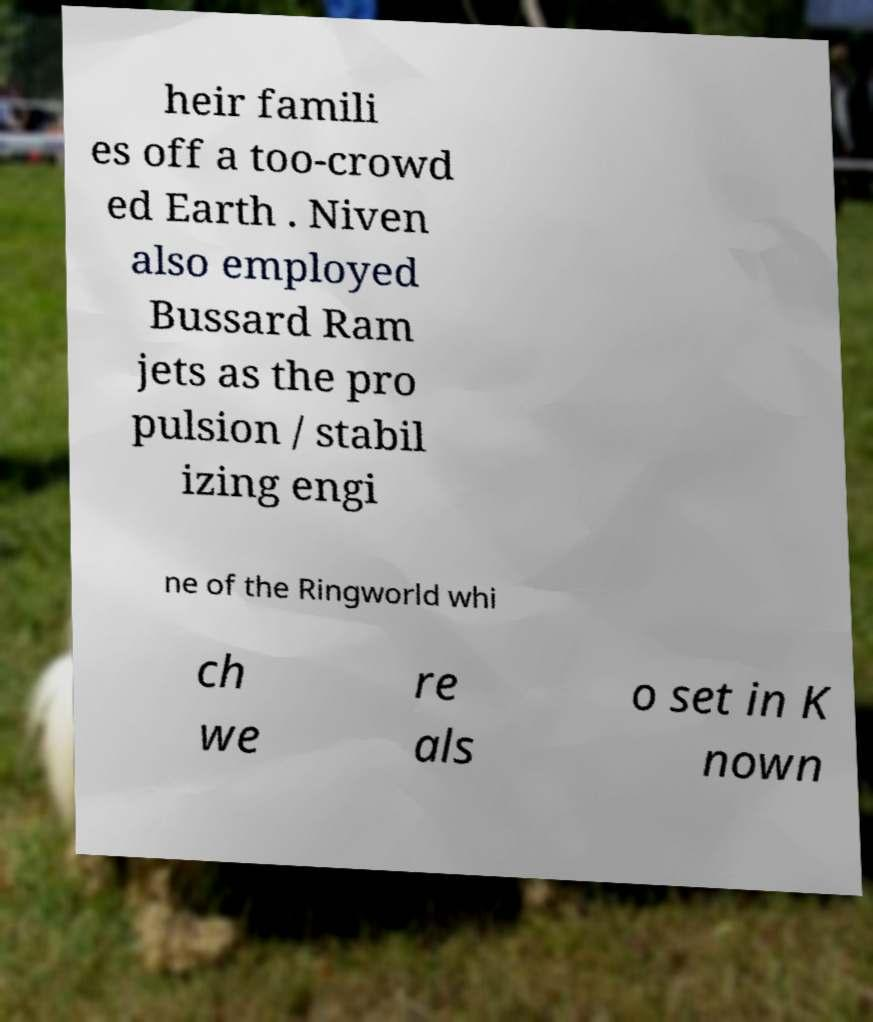Can you read and provide the text displayed in the image?This photo seems to have some interesting text. Can you extract and type it out for me? heir famili es off a too-crowd ed Earth . Niven also employed Bussard Ram jets as the pro pulsion / stabil izing engi ne of the Ringworld whi ch we re als o set in K nown 